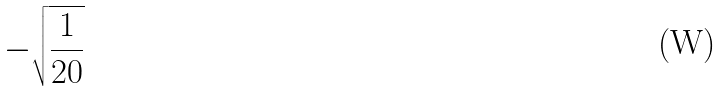Convert formula to latex. <formula><loc_0><loc_0><loc_500><loc_500>- \sqrt { \frac { 1 } { 2 0 } }</formula> 